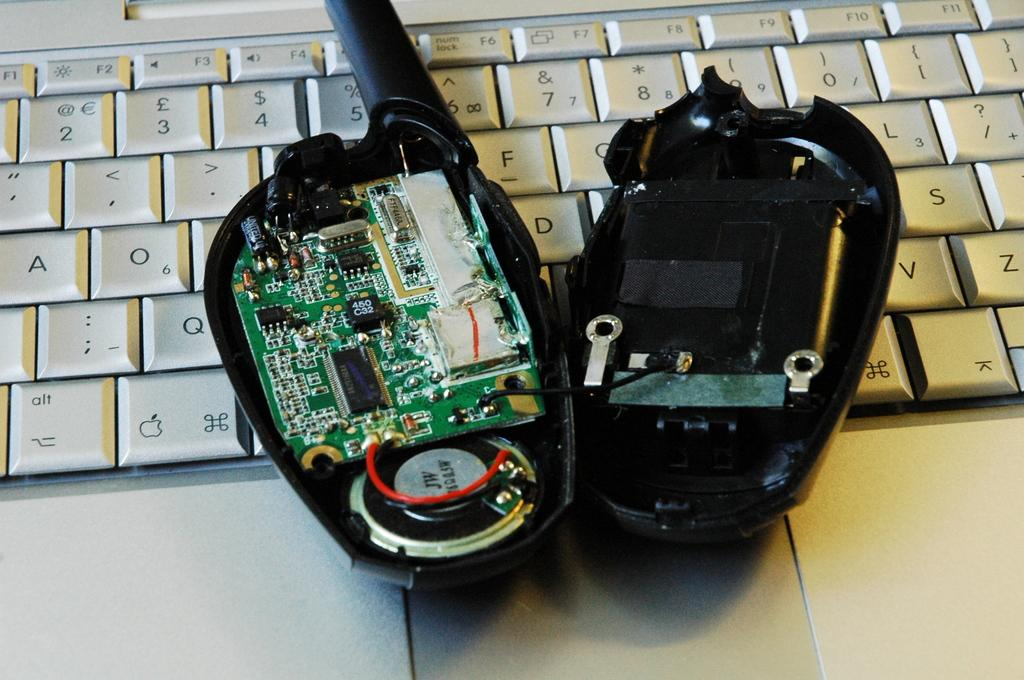What type of communication device is visible in the image? There is an opened walkie talkie in the image. What is the walkie talkie placed on in the image? The walkie talkie is on a laptop. What color is the paint on the sky in the image? There is no paint or sky present in the image; it only features an opened walkie talkie on a laptop. How many links are in the chain that is hanging from the walkie talkie? There is no chain present in the image; it only features an opened walkie talkie on a laptop. 